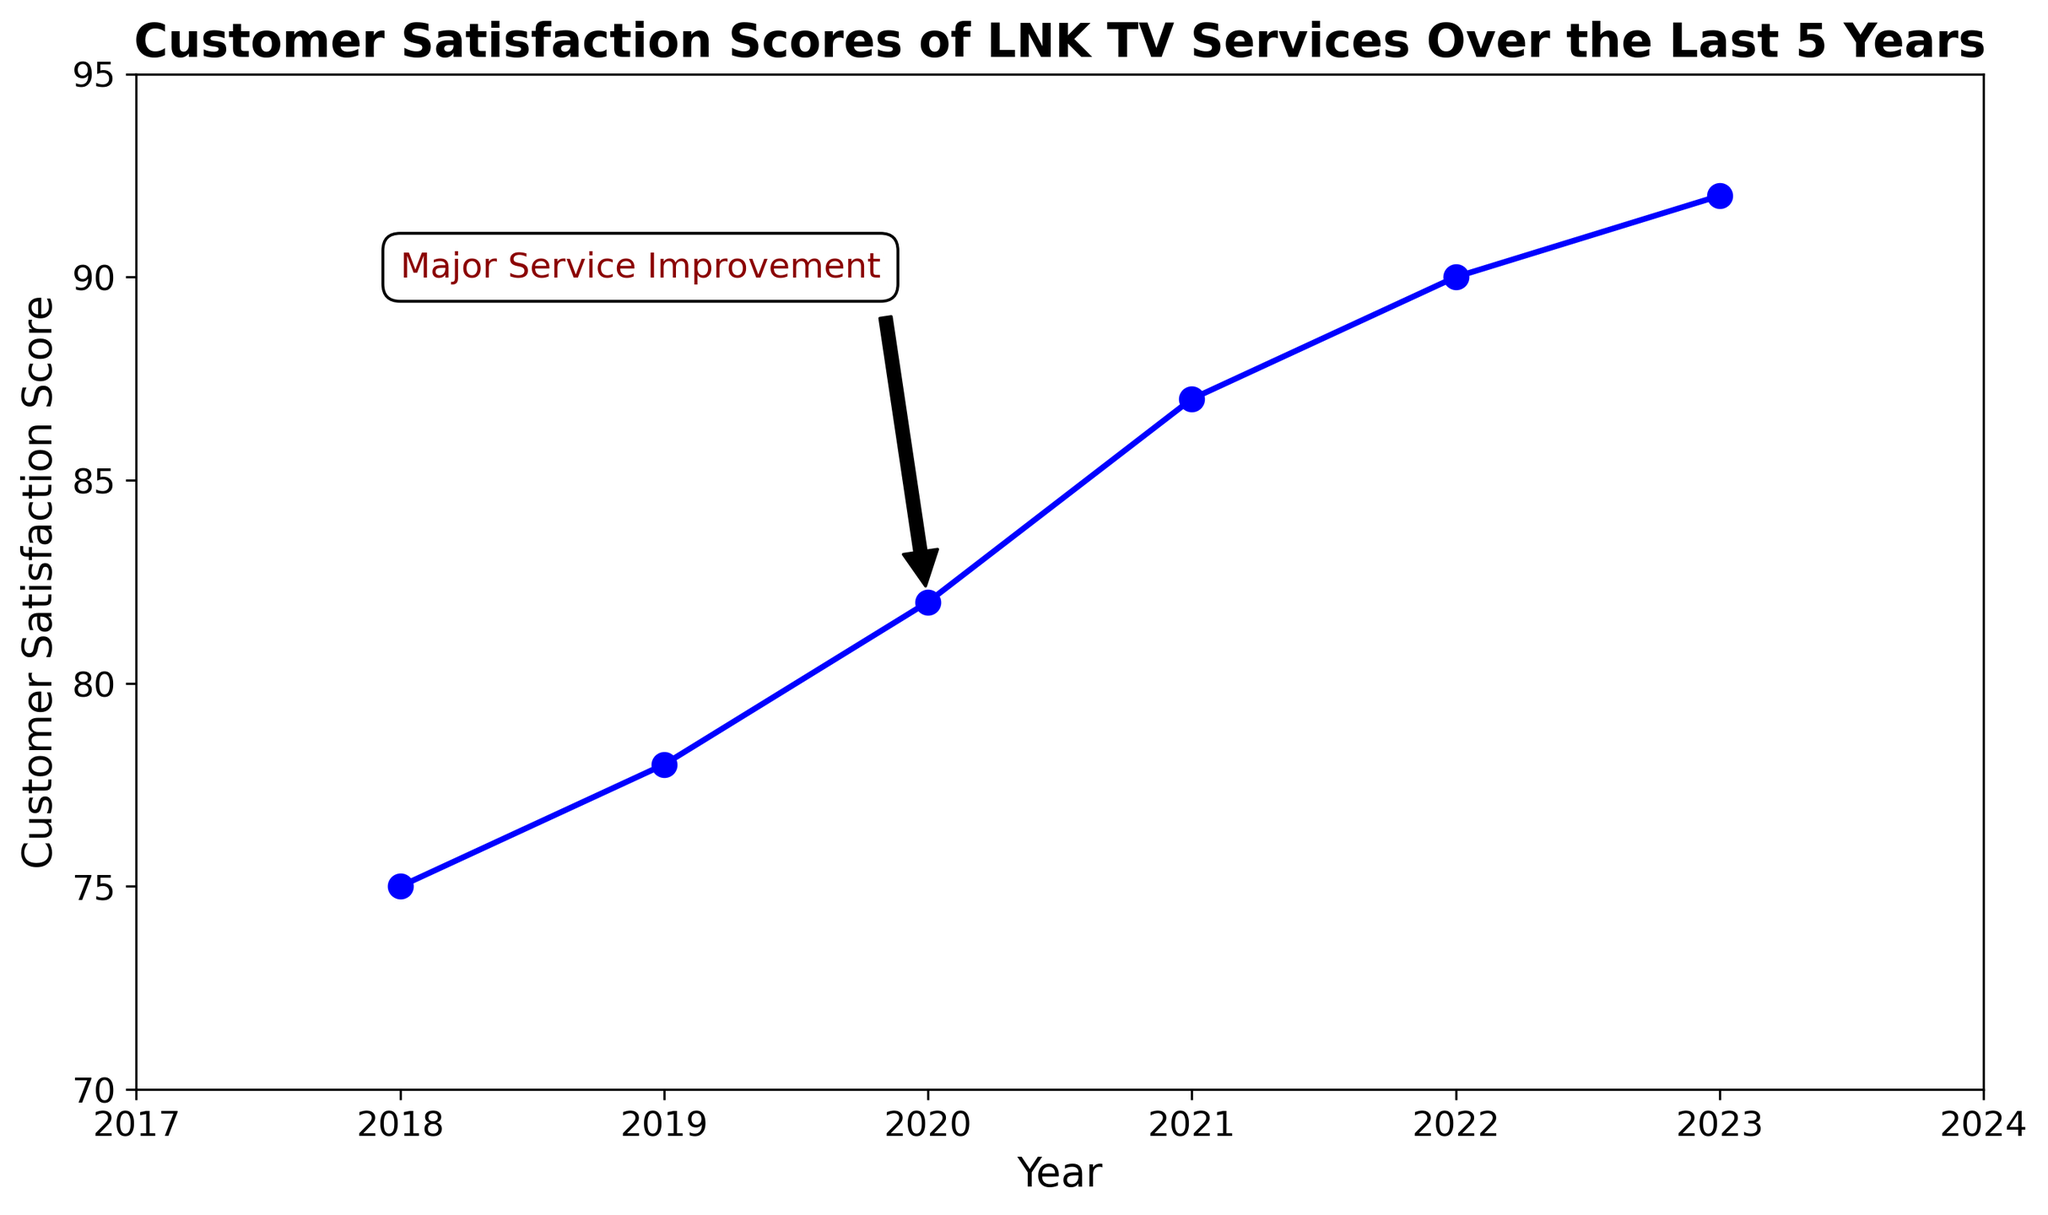What was the Customer Satisfaction Score in the year 2020? Identify the score for the year 2020 from the plotted values. The point for 2020 is marked at the value of 82.
Answer: 82 What was the percentage increase in Customer Satisfaction Score from 2019 to 2020? Calculate the difference in scores between 2019 and 2020, then divide by the 2019 score, and multiply by 100 to get the percentage. The increase is (82 - 78)/78 * 100 = 5.13%.
Answer: 5.13% What is the difference between the Customer Satisfaction Scores for the years 2021 and 2023? Subtract the 2021 score from the 2023 score: 92 - 87 = 5.
Answer: 5 Which year had the highest Customer Satisfaction Score? Look at the plot to find the highest point, which corresponds to the year 2023 with a score of 92.
Answer: 2023 What is the average Customer Satisfaction Score over the last 5 years, excluding 2023? Calculate the mean of the scores from 2018 to 2022: (75 + 78 + 82 + 87 + 90) / 5 = 82.4.
Answer: 82.4 How much did the Customer Satisfaction Score increase after the Major Service Improvement in 2020? First, find the score in 2020 (82), then compare it to the 2021 score (87). The increase is 87 - 82 = 5.
Answer: 5 By how many points did the Customer Satisfaction Score increase from 2018 to 2023? Subtract the 2018 score from the 2023 score: 92 - 75 = 17.
Answer: 17 Did the Customer Satisfaction Score ever decrease over the last 5 years? Analyze the trend of the line. Since it is increasing every year, no decrease is observed.
Answer: No 